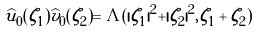Convert formula to latex. <formula><loc_0><loc_0><loc_500><loc_500>\widehat { u } _ { 0 } ( \zeta _ { 1 } ) \widehat { v } _ { 0 } ( \zeta _ { 2 } ) = \Lambda ( | \zeta _ { 1 } | ^ { 2 } + | \zeta _ { 2 } | ^ { 2 } , \zeta _ { 1 } + \zeta _ { 2 } )</formula> 